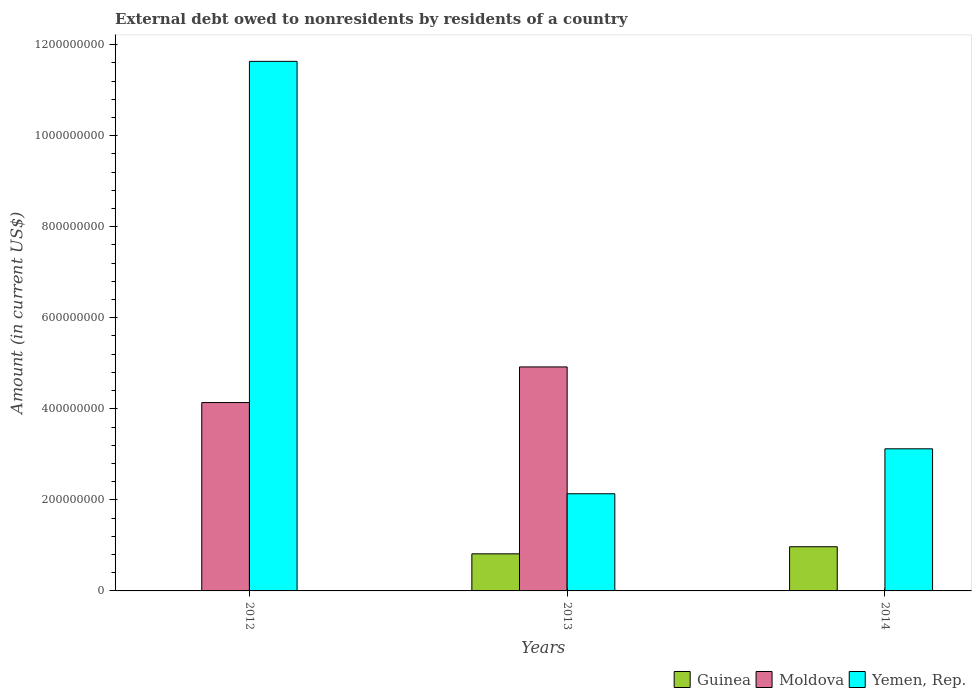How many bars are there on the 2nd tick from the left?
Your response must be concise. 3. How many bars are there on the 1st tick from the right?
Offer a very short reply. 2. Across all years, what is the maximum external debt owed by residents in Guinea?
Offer a very short reply. 9.70e+07. In which year was the external debt owed by residents in Guinea maximum?
Give a very brief answer. 2014. What is the total external debt owed by residents in Moldova in the graph?
Provide a short and direct response. 9.06e+08. What is the difference between the external debt owed by residents in Yemen, Rep. in 2012 and that in 2014?
Give a very brief answer. 8.51e+08. What is the difference between the external debt owed by residents in Yemen, Rep. in 2014 and the external debt owed by residents in Moldova in 2013?
Offer a very short reply. -1.80e+08. What is the average external debt owed by residents in Moldova per year?
Provide a short and direct response. 3.02e+08. In the year 2014, what is the difference between the external debt owed by residents in Guinea and external debt owed by residents in Yemen, Rep.?
Ensure brevity in your answer.  -2.15e+08. In how many years, is the external debt owed by residents in Moldova greater than 320000000 US$?
Make the answer very short. 2. What is the ratio of the external debt owed by residents in Guinea in 2013 to that in 2014?
Your response must be concise. 0.84. Is the external debt owed by residents in Moldova in 2012 less than that in 2013?
Your response must be concise. Yes. What is the difference between the highest and the second highest external debt owed by residents in Yemen, Rep.?
Your answer should be compact. 8.51e+08. What is the difference between the highest and the lowest external debt owed by residents in Yemen, Rep.?
Your answer should be compact. 9.50e+08. In how many years, is the external debt owed by residents in Moldova greater than the average external debt owed by residents in Moldova taken over all years?
Give a very brief answer. 2. Is the sum of the external debt owed by residents in Yemen, Rep. in 2012 and 2013 greater than the maximum external debt owed by residents in Moldova across all years?
Provide a short and direct response. Yes. Is it the case that in every year, the sum of the external debt owed by residents in Guinea and external debt owed by residents in Yemen, Rep. is greater than the external debt owed by residents in Moldova?
Your answer should be very brief. No. How many years are there in the graph?
Your answer should be compact. 3. How are the legend labels stacked?
Your answer should be compact. Horizontal. What is the title of the graph?
Ensure brevity in your answer.  External debt owed to nonresidents by residents of a country. What is the label or title of the X-axis?
Keep it short and to the point. Years. What is the label or title of the Y-axis?
Give a very brief answer. Amount (in current US$). What is the Amount (in current US$) in Moldova in 2012?
Keep it short and to the point. 4.14e+08. What is the Amount (in current US$) in Yemen, Rep. in 2012?
Offer a terse response. 1.16e+09. What is the Amount (in current US$) in Guinea in 2013?
Your answer should be very brief. 8.15e+07. What is the Amount (in current US$) of Moldova in 2013?
Give a very brief answer. 4.92e+08. What is the Amount (in current US$) in Yemen, Rep. in 2013?
Give a very brief answer. 2.13e+08. What is the Amount (in current US$) in Guinea in 2014?
Your answer should be compact. 9.70e+07. What is the Amount (in current US$) in Yemen, Rep. in 2014?
Your answer should be compact. 3.12e+08. Across all years, what is the maximum Amount (in current US$) of Guinea?
Keep it short and to the point. 9.70e+07. Across all years, what is the maximum Amount (in current US$) of Moldova?
Offer a very short reply. 4.92e+08. Across all years, what is the maximum Amount (in current US$) of Yemen, Rep.?
Provide a succinct answer. 1.16e+09. Across all years, what is the minimum Amount (in current US$) of Yemen, Rep.?
Your response must be concise. 2.13e+08. What is the total Amount (in current US$) in Guinea in the graph?
Keep it short and to the point. 1.79e+08. What is the total Amount (in current US$) of Moldova in the graph?
Your answer should be very brief. 9.06e+08. What is the total Amount (in current US$) in Yemen, Rep. in the graph?
Your response must be concise. 1.69e+09. What is the difference between the Amount (in current US$) in Moldova in 2012 and that in 2013?
Offer a very short reply. -7.83e+07. What is the difference between the Amount (in current US$) of Yemen, Rep. in 2012 and that in 2013?
Keep it short and to the point. 9.50e+08. What is the difference between the Amount (in current US$) of Yemen, Rep. in 2012 and that in 2014?
Offer a terse response. 8.51e+08. What is the difference between the Amount (in current US$) of Guinea in 2013 and that in 2014?
Provide a succinct answer. -1.56e+07. What is the difference between the Amount (in current US$) in Yemen, Rep. in 2013 and that in 2014?
Keep it short and to the point. -9.88e+07. What is the difference between the Amount (in current US$) in Moldova in 2012 and the Amount (in current US$) in Yemen, Rep. in 2013?
Your answer should be compact. 2.00e+08. What is the difference between the Amount (in current US$) in Moldova in 2012 and the Amount (in current US$) in Yemen, Rep. in 2014?
Offer a terse response. 1.02e+08. What is the difference between the Amount (in current US$) of Guinea in 2013 and the Amount (in current US$) of Yemen, Rep. in 2014?
Your answer should be compact. -2.31e+08. What is the difference between the Amount (in current US$) in Moldova in 2013 and the Amount (in current US$) in Yemen, Rep. in 2014?
Your response must be concise. 1.80e+08. What is the average Amount (in current US$) of Guinea per year?
Your response must be concise. 5.95e+07. What is the average Amount (in current US$) in Moldova per year?
Keep it short and to the point. 3.02e+08. What is the average Amount (in current US$) in Yemen, Rep. per year?
Your response must be concise. 5.63e+08. In the year 2012, what is the difference between the Amount (in current US$) of Moldova and Amount (in current US$) of Yemen, Rep.?
Your answer should be compact. -7.49e+08. In the year 2013, what is the difference between the Amount (in current US$) of Guinea and Amount (in current US$) of Moldova?
Your response must be concise. -4.11e+08. In the year 2013, what is the difference between the Amount (in current US$) of Guinea and Amount (in current US$) of Yemen, Rep.?
Offer a terse response. -1.32e+08. In the year 2013, what is the difference between the Amount (in current US$) in Moldova and Amount (in current US$) in Yemen, Rep.?
Give a very brief answer. 2.79e+08. In the year 2014, what is the difference between the Amount (in current US$) of Guinea and Amount (in current US$) of Yemen, Rep.?
Offer a terse response. -2.15e+08. What is the ratio of the Amount (in current US$) of Moldova in 2012 to that in 2013?
Make the answer very short. 0.84. What is the ratio of the Amount (in current US$) in Yemen, Rep. in 2012 to that in 2013?
Your answer should be very brief. 5.45. What is the ratio of the Amount (in current US$) of Yemen, Rep. in 2012 to that in 2014?
Ensure brevity in your answer.  3.73. What is the ratio of the Amount (in current US$) in Guinea in 2013 to that in 2014?
Ensure brevity in your answer.  0.84. What is the ratio of the Amount (in current US$) in Yemen, Rep. in 2013 to that in 2014?
Ensure brevity in your answer.  0.68. What is the difference between the highest and the second highest Amount (in current US$) of Yemen, Rep.?
Your answer should be compact. 8.51e+08. What is the difference between the highest and the lowest Amount (in current US$) of Guinea?
Make the answer very short. 9.70e+07. What is the difference between the highest and the lowest Amount (in current US$) of Moldova?
Your answer should be very brief. 4.92e+08. What is the difference between the highest and the lowest Amount (in current US$) in Yemen, Rep.?
Offer a very short reply. 9.50e+08. 